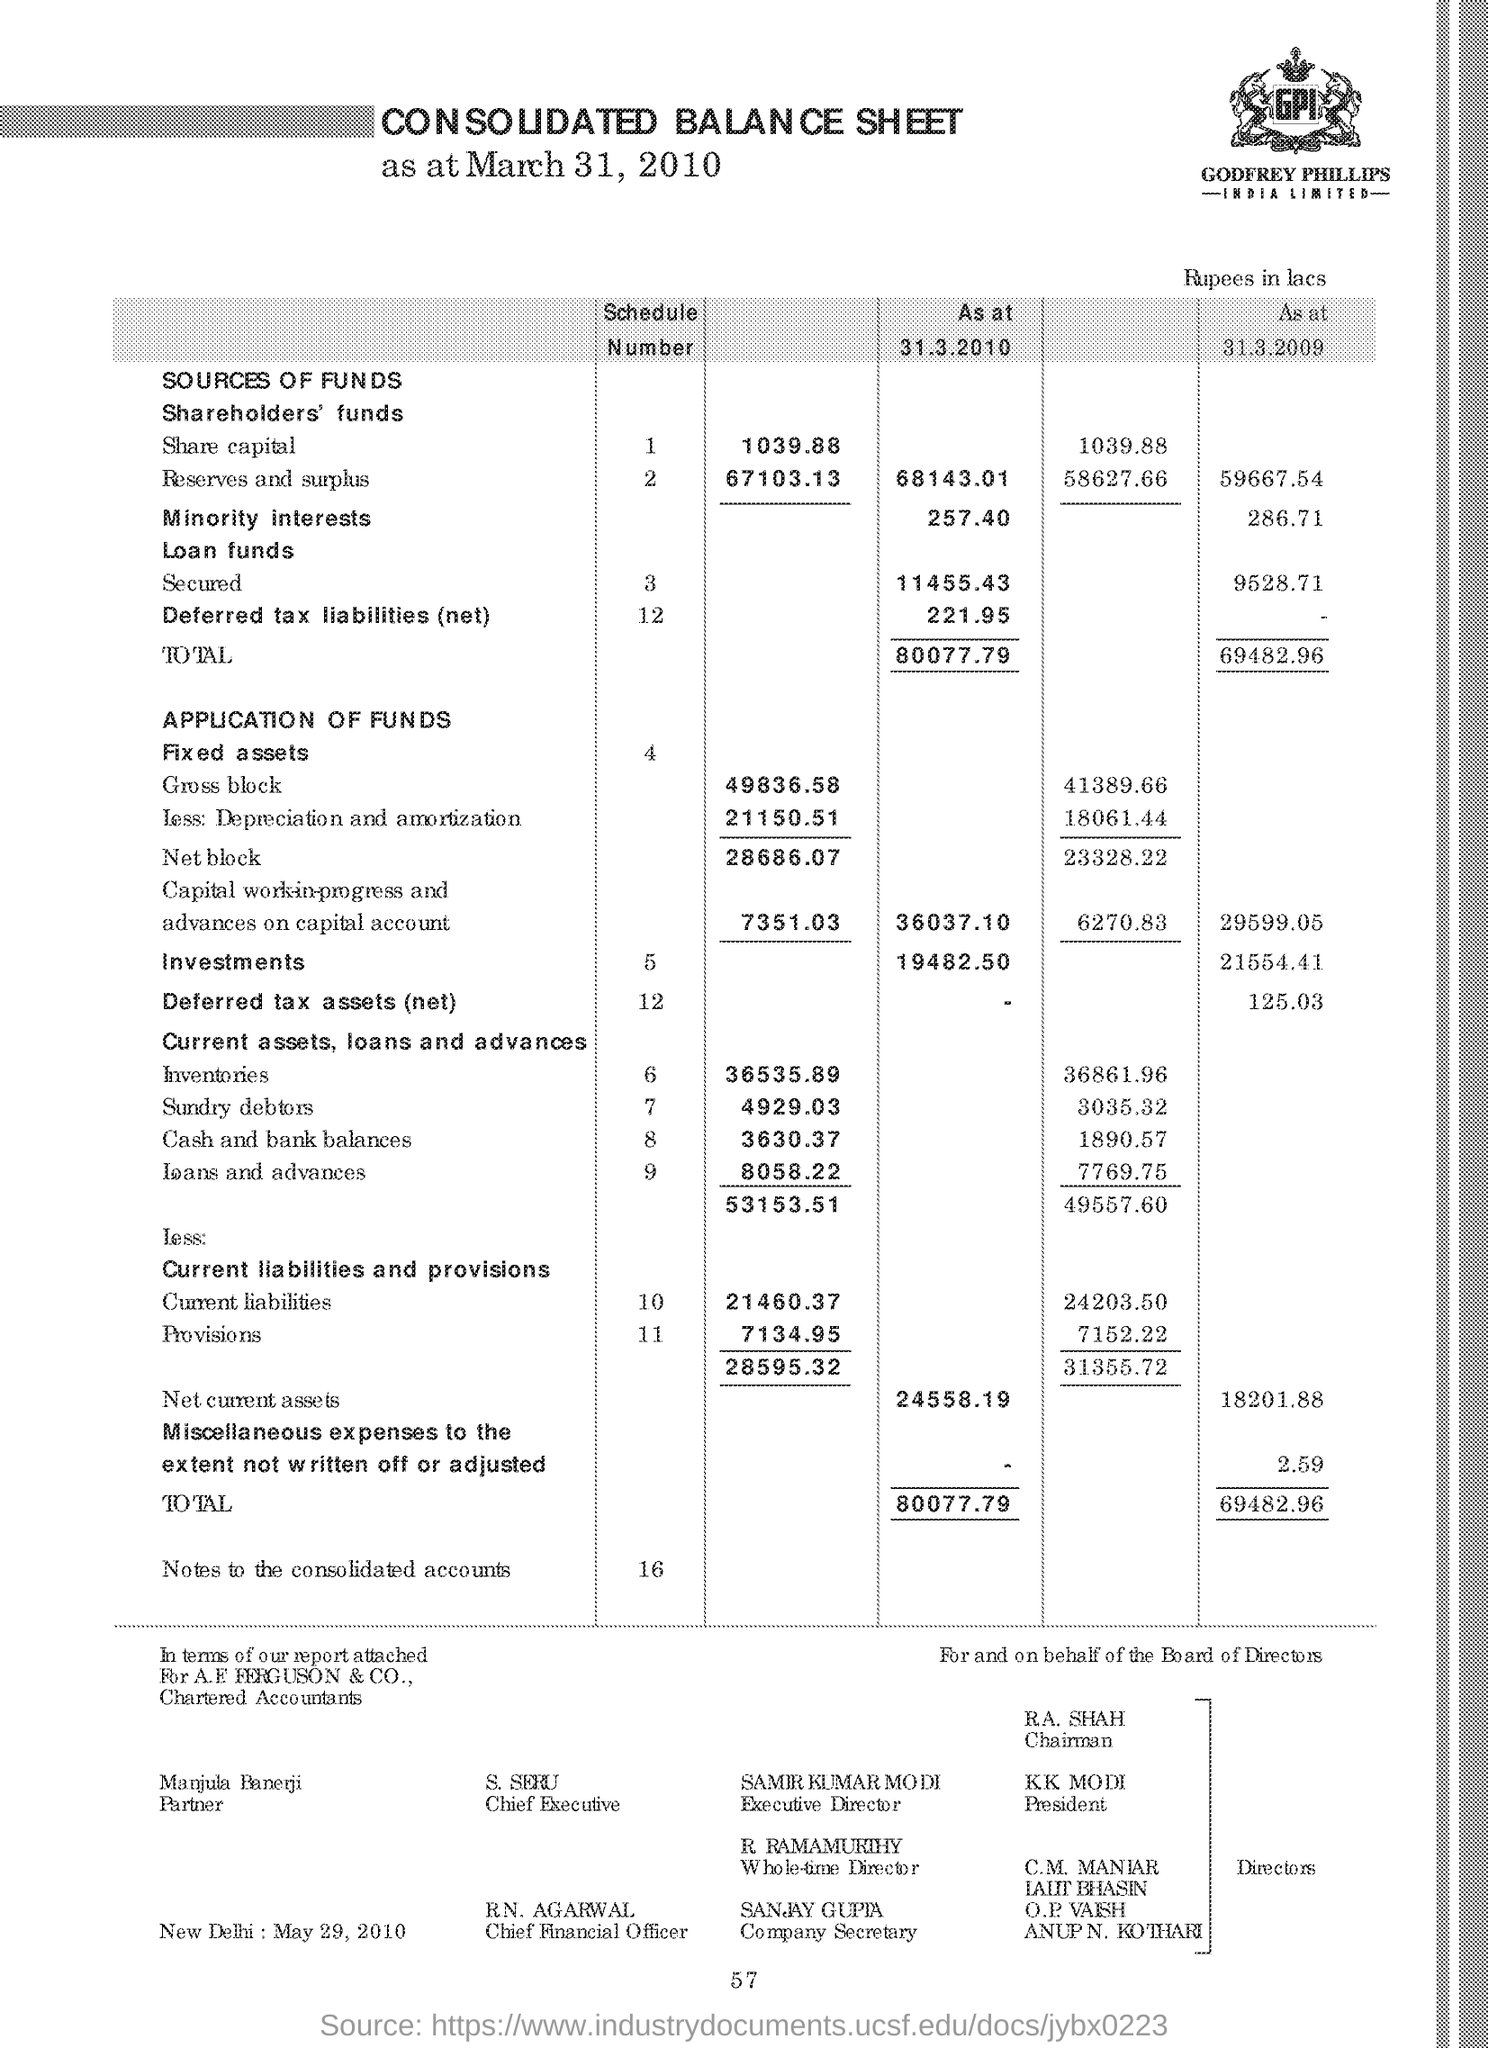Who is the chairman ?
Your answer should be very brief. R.A. SHAH. Who is the president ?
Give a very brief answer. K.K. Modi. Who is the executive director ?
Your answer should be compact. Samir kumar modi. Who is the whole time director
Your answer should be compact. R. Ramamurthy. Who is the company secretary
Your response must be concise. Sanjay gupta. Who is the chief executive ?
Your answer should be very brief. S. Seru. Who is the partner ?
Ensure brevity in your answer.  Manjula banerji. 